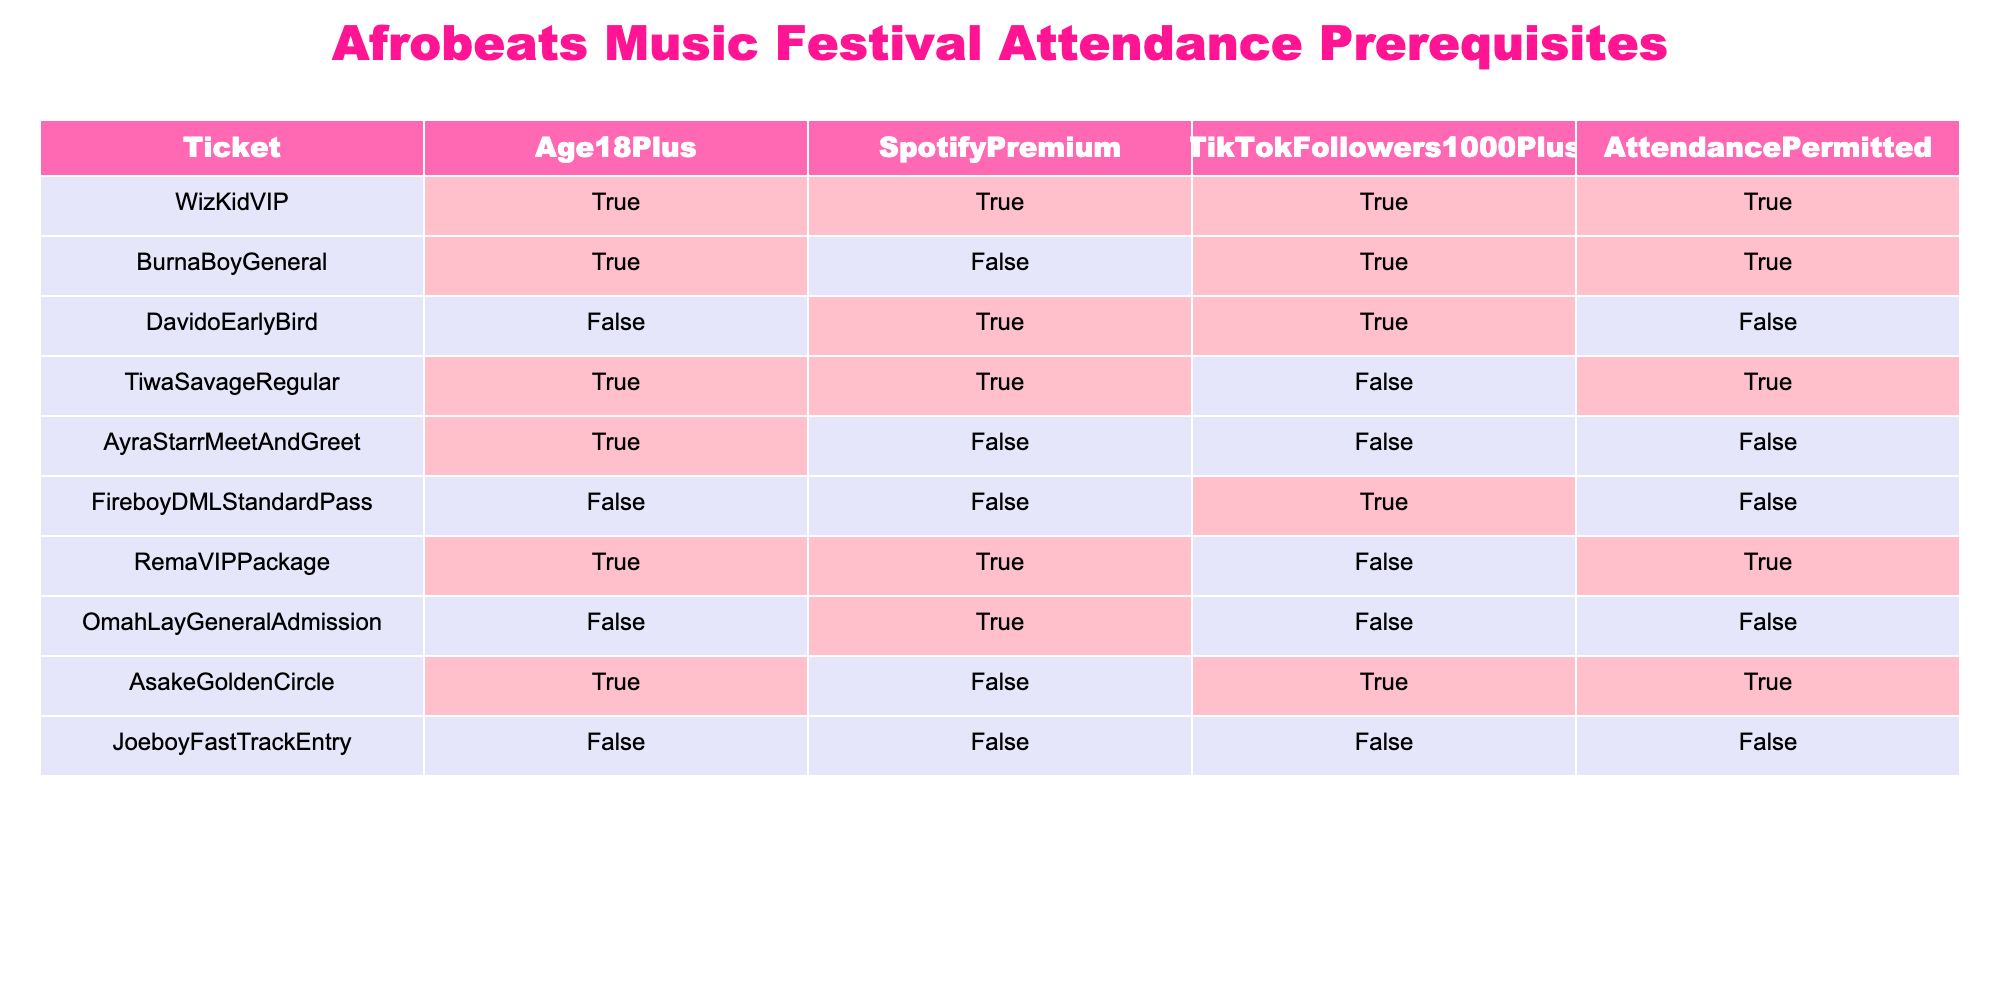What is the ticket type with the requirement of having Spotify Premium and being 18+? The table shows that the ticket type "WizKidVIP" meets both the Spotify Premium and age 18+ criteria. It lists TRUE for both prerequisites.
Answer: WizKidVIP How many ticket types permit attendance without the need for TikTok followers? Looking at the table, the following tickets permit attendance with FALSE for TikTok followers: "WizKidVIP," "BurnaBoyGeneral," "TiwaSavageRegular," "RemaVIPPackage," and "AsakeGoldenCircle." This is a total of 5 tickets.
Answer: 5 Is it possible to attend the music festival with an age under 18 and Spotify Premium? The tickets "DavidoEarlyBird," "OmahLayGeneralAdmission," and "FireboyDMLStandardPass" all show FALSE for the under 18 age requirement, thus making it impossible to attend the festival while meeting these conditions.
Answer: No How many total ticket types allow attendance based only on being 18+ and having fewer than 1000 TikTok followers? The relevant ticket types that allow attendance under these conditions are "BurnaBoyGeneral," "TiwaSavageRegular," and "RemaVIPPackage." Each of these has TRUE under Age 18+ and FALSE under TikTok followers. There are 3 valid ticket types.
Answer: 3 Which ticket is available for those who are 18+, do not have Spotify Premium, and have over 1000 TikTok followers? "OmahLayGeneralAdmission" is the ticket type that satisfies these conditions. The table shows that it has FALSE for the age requirement, TRUE for Spotify Premium, and FALSE for TikTok followers, which does not meet all conditions, so no ticket meets this requirement.
Answer: None What is the total number of tickets allowing attendance that require both being 18+ and having Spotify Premium? The tickets "WizKidVIP," "BurnaBoyGeneral," "TiwaSavageRegular," and "RemaVIPPackage" are applicable. The requirement is TRUE for both criteria in these ticket types, resulting in a total of 4 tickets that allow attendance.
Answer: 4 Do any ticket types allow attendance if both the Spotify Premium and TikTok followers conditions are FALSE? Only the "JoeboyFastTrackEntry" shows FALSE for both Spotify Premium and TikTok followers but also shows FALSE for age 18+, thus it does not allow attendance. Therefore, no tickets allow attendance under those conditions.
Answer: No Which ticket type allows attendance with only one criterion being FALSE? The ticket "BurnaBoyGeneral" has FALSE for Spotify Premium but meets the other criteria (is 18+ and has over 1000 TikTok followers), allowing attendance. This means it allows entry with one FALSE condition present.
Answer: BurnaBoyGeneral 